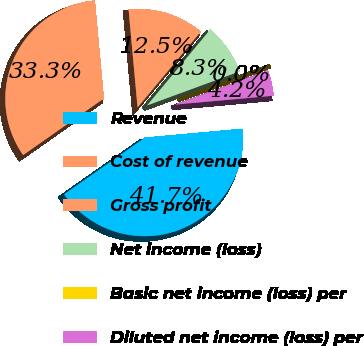Convert chart. <chart><loc_0><loc_0><loc_500><loc_500><pie_chart><fcel>Revenue<fcel>Cost of revenue<fcel>Gross profit<fcel>Net income (loss)<fcel>Basic net income (loss) per<fcel>Diluted net income (loss) per<nl><fcel>41.7%<fcel>33.28%<fcel>12.51%<fcel>8.34%<fcel>0.0%<fcel>4.17%<nl></chart> 